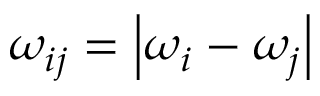Convert formula to latex. <formula><loc_0><loc_0><loc_500><loc_500>\omega _ { i j } = \left | \omega _ { i } - \omega _ { j } \right |</formula> 